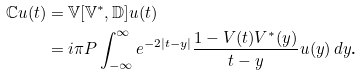Convert formula to latex. <formula><loc_0><loc_0><loc_500><loc_500>\mathbb { C } u ( t ) & = \mathbb { V } [ \mathbb { V } ^ { * } , \mathbb { D } ] u ( t ) \\ & = i \pi P \int _ { - \infty } ^ { \infty } e ^ { - 2 | t - y | } \frac { 1 - V ( t ) V ^ { * } ( y ) } { t - y } u ( y ) \, d y \text {.}</formula> 